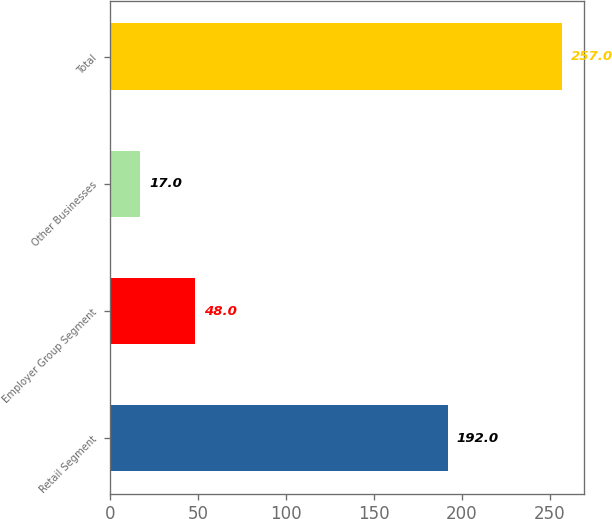Convert chart to OTSL. <chart><loc_0><loc_0><loc_500><loc_500><bar_chart><fcel>Retail Segment<fcel>Employer Group Segment<fcel>Other Businesses<fcel>Total<nl><fcel>192<fcel>48<fcel>17<fcel>257<nl></chart> 